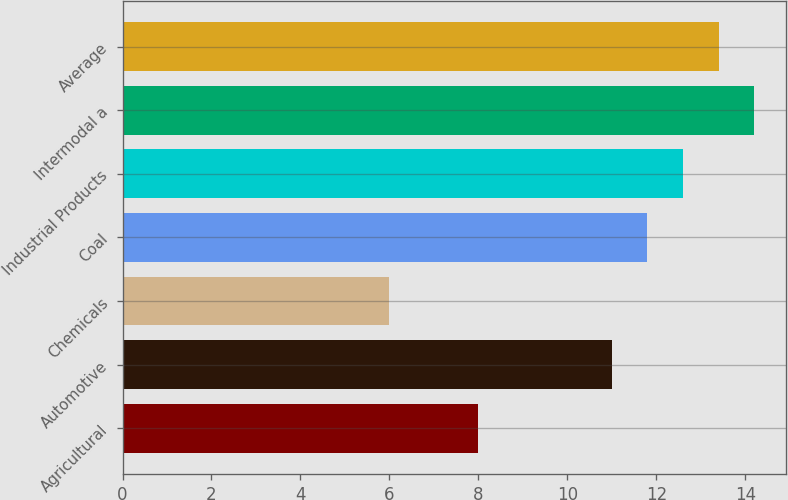Convert chart to OTSL. <chart><loc_0><loc_0><loc_500><loc_500><bar_chart><fcel>Agricultural<fcel>Automotive<fcel>Chemicals<fcel>Coal<fcel>Industrial Products<fcel>Intermodal a<fcel>Average<nl><fcel>8<fcel>11<fcel>6<fcel>11.8<fcel>12.6<fcel>14.2<fcel>13.4<nl></chart> 